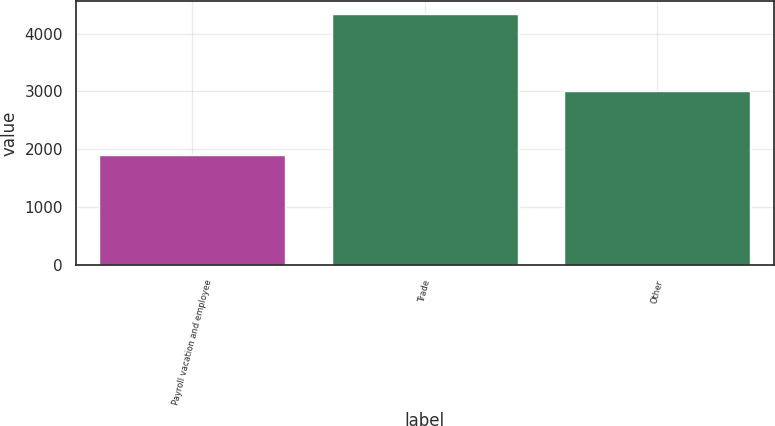Convert chart to OTSL. <chart><loc_0><loc_0><loc_500><loc_500><bar_chart><fcel>Payroll vacation and employee<fcel>Trade<fcel>Other<nl><fcel>1899<fcel>4344<fcel>3003<nl></chart> 